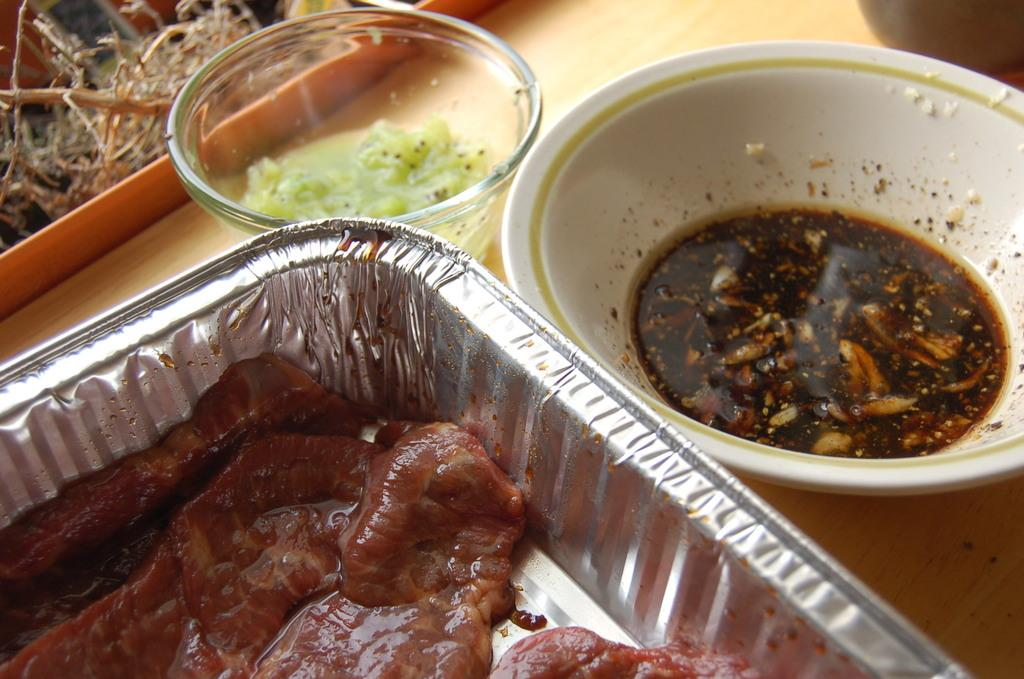What can be seen in the bowls in the image? There are food items in the bowls in the image. Where are the bowls located? The bowls are placed on a table. What type of baseball equipment can be seen in the image? There is no baseball equipment present in the image. 